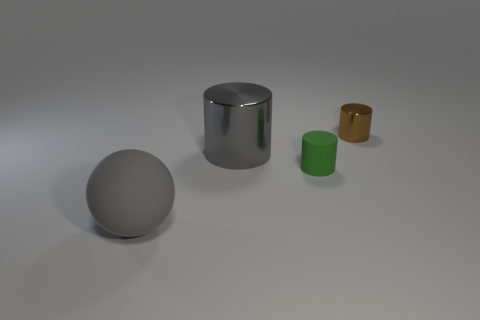Add 4 small brown balls. How many objects exist? 8 Subtract all spheres. How many objects are left? 3 Subtract all gray cylinders. Subtract all gray rubber spheres. How many objects are left? 2 Add 4 large gray rubber things. How many large gray rubber things are left? 5 Add 2 gray matte blocks. How many gray matte blocks exist? 2 Subtract 0 blue blocks. How many objects are left? 4 